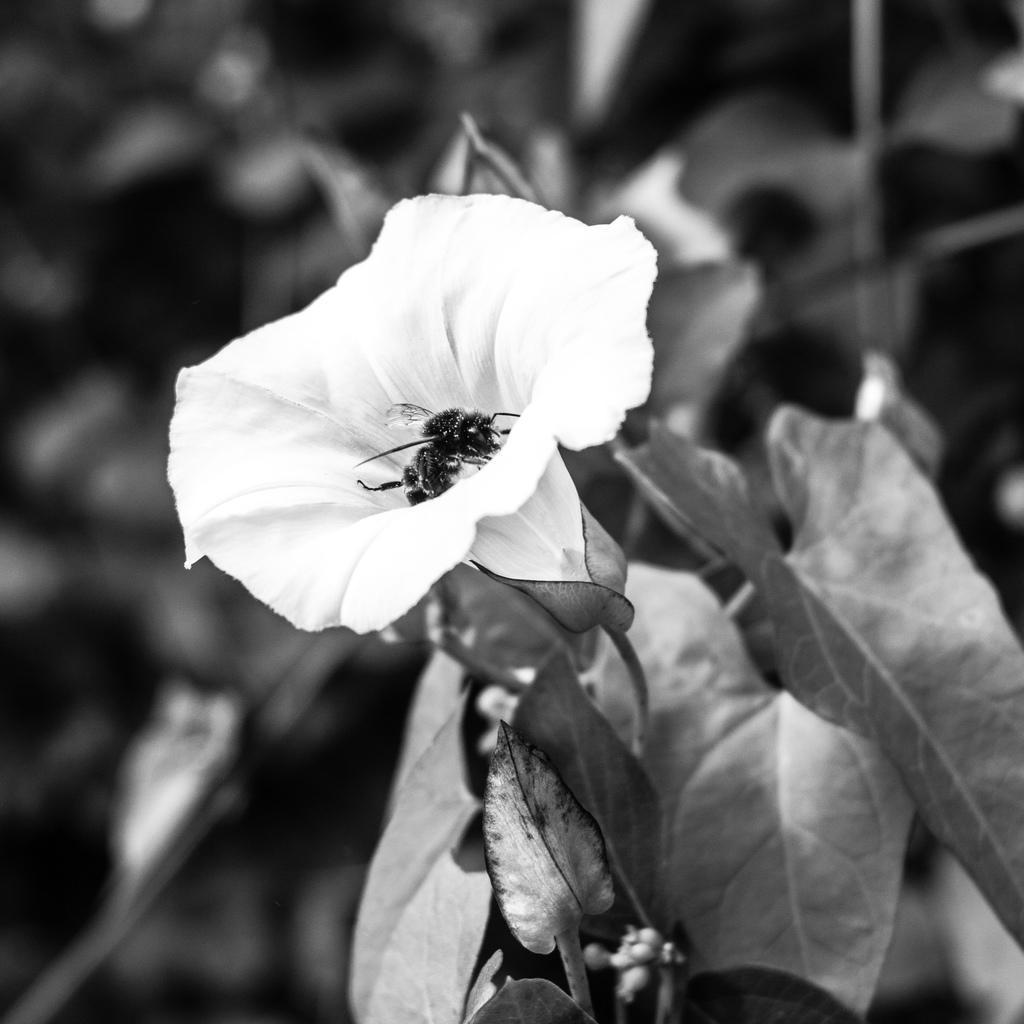Can you describe this image briefly? This is a black and white image. Background portion of the picture is blur. In this picture we can see a flower and leaves. 